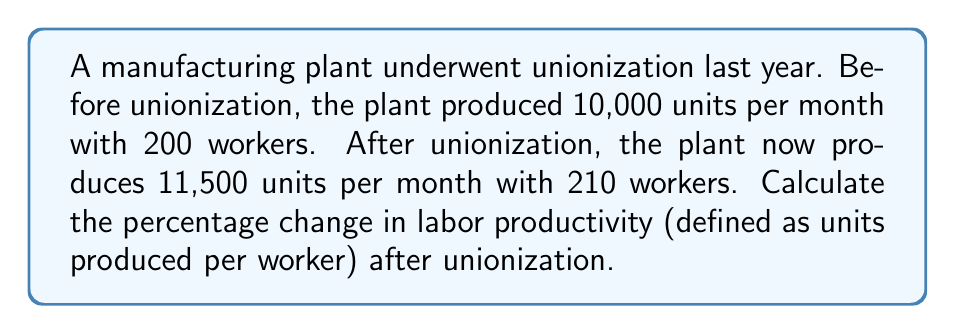Help me with this question. To solve this problem, we need to follow these steps:

1. Calculate the labor productivity before unionization:
   $$\text{Productivity}_{\text{before}} = \frac{\text{Units produced}}{\text{Number of workers}} = \frac{10,000}{200} = 50 \text{ units per worker}$$

2. Calculate the labor productivity after unionization:
   $$\text{Productivity}_{\text{after}} = \frac{\text{Units produced}}{\text{Number of workers}} = \frac{11,500}{210} \approx 54.76 \text{ units per worker}$$

3. Calculate the change in productivity:
   $$\text{Change} = \text{Productivity}_{\text{after}} - \text{Productivity}_{\text{before}} = 54.76 - 50 = 4.76 \text{ units per worker}$$

4. Calculate the percentage change:
   $$\text{Percentage change} = \frac{\text{Change}}{\text{Productivity}_{\text{before}}} \times 100\%$$
   $$= \frac{4.76}{50} \times 100\% = 0.0952 \times 100\% = 9.52\%$$

Therefore, the percentage change in labor productivity after unionization is approximately 9.52%.
Answer: The percentage change in labor productivity after unionization is approximately 9.52%. 